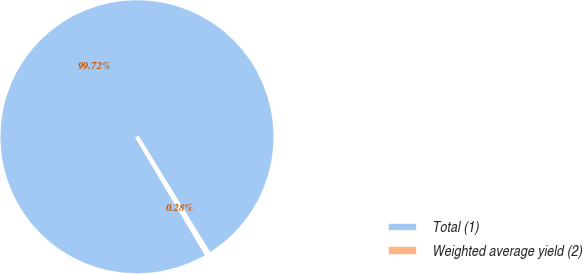<chart> <loc_0><loc_0><loc_500><loc_500><pie_chart><fcel>Total (1)<fcel>Weighted average yield (2)<nl><fcel>99.72%<fcel>0.28%<nl></chart> 